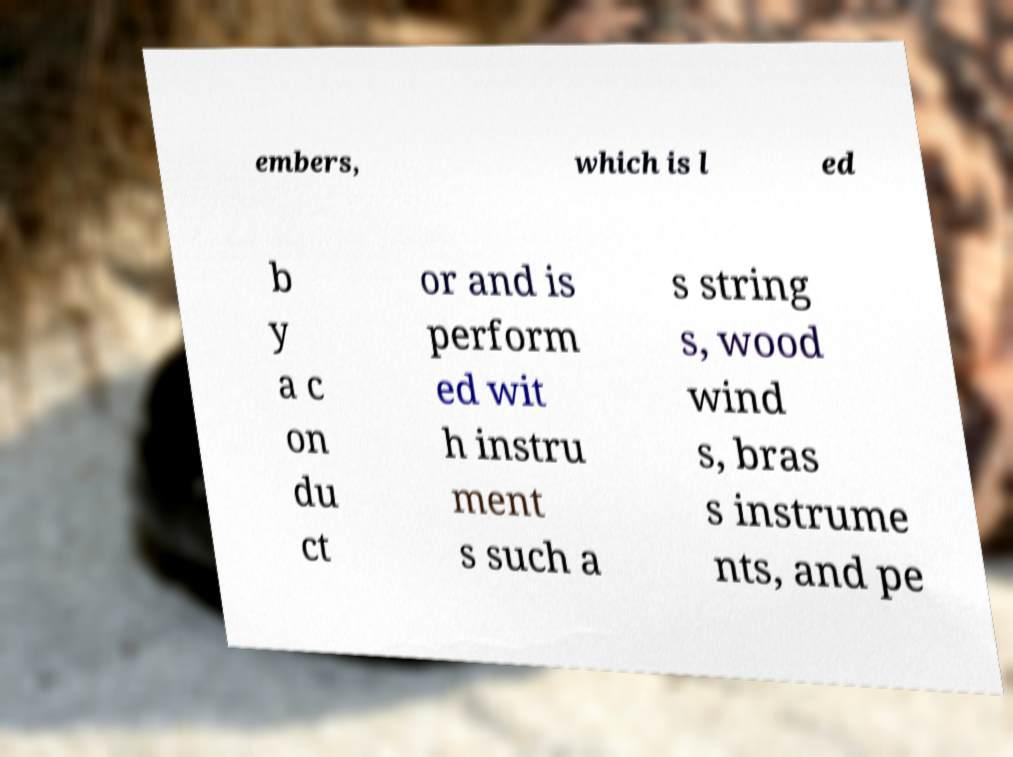Could you assist in decoding the text presented in this image and type it out clearly? embers, which is l ed b y a c on du ct or and is perform ed wit h instru ment s such a s string s, wood wind s, bras s instrume nts, and pe 